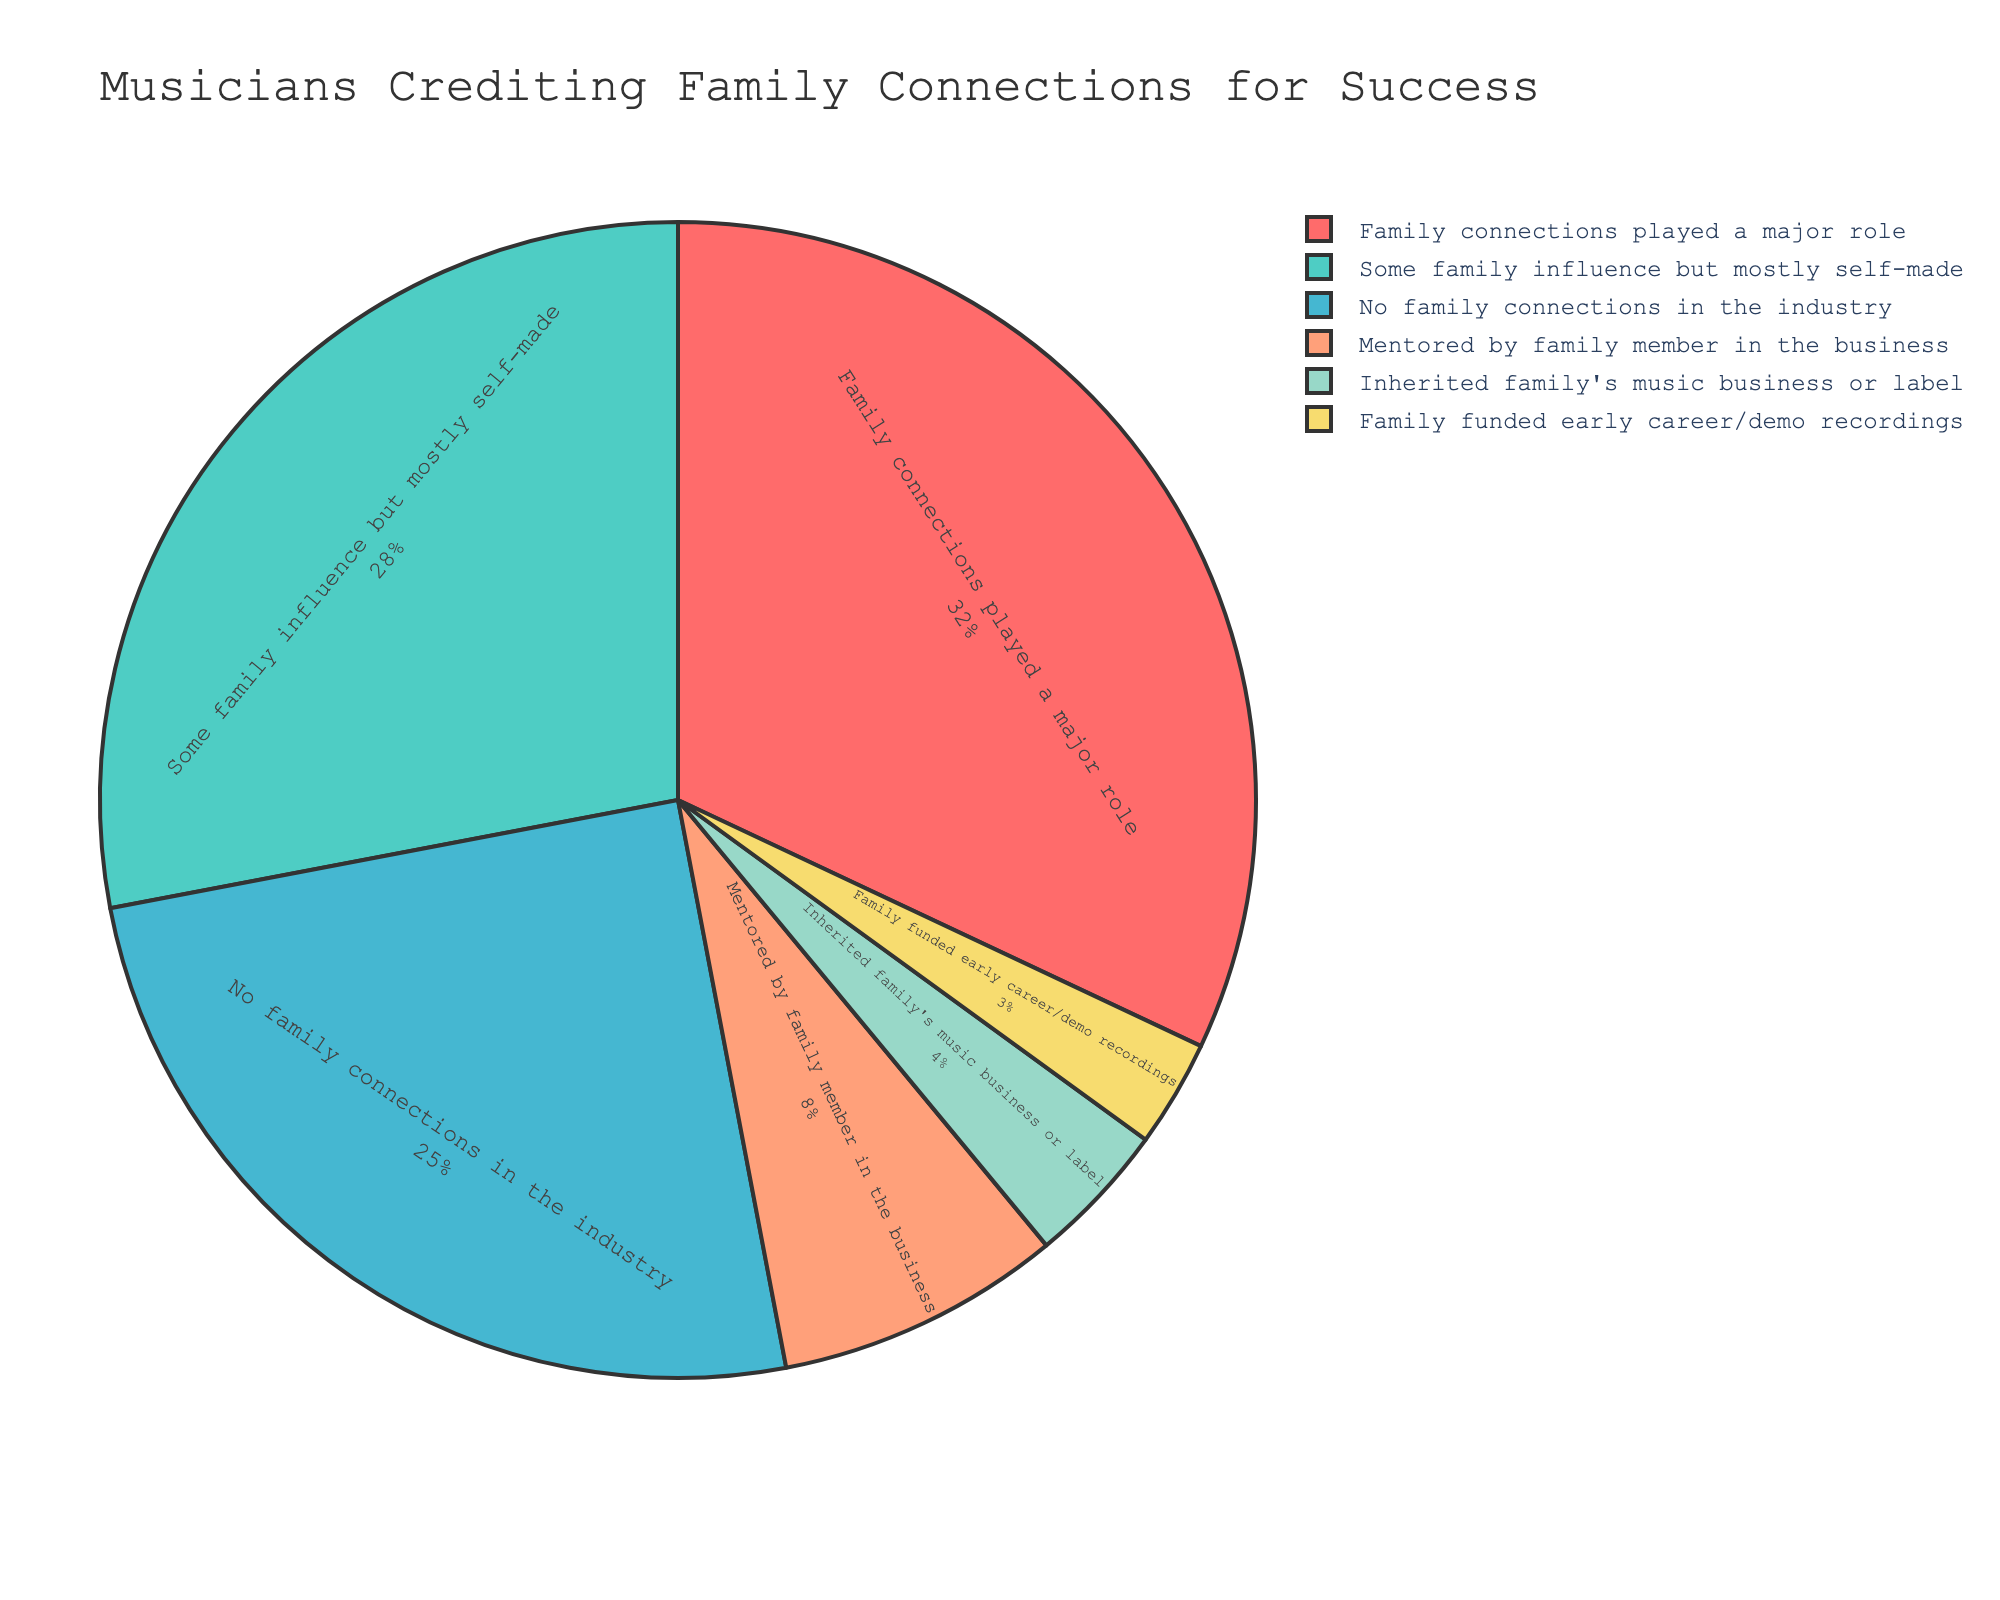Which category has the highest percentage? From the pie chart, "Family connections played a major role" has the largest slice, indicating it has the highest percentage.
Answer: Family connections played a major role What is the combined percentage of musicians who had some family influence but are mostly self-made and those mentored by a family member in the business? To determine the combined percentage, add the percentages of "Some family influence but mostly self-made" (28%) and "Mentored by family member in the business" (8%): 28 + 8 = 36%
Answer: 36% Which category has a lower percentage than those who had no family connections in the industry? "Inherited family's music business or label" (4%) and "Family funded early career/demo recordings" (3%) have lower percentages compared to "No family connections in the industry" (25%).
Answer: Inherited family's music business or label and Family funded early career/demo recordings How does the percentage of musicians who credit family connections as having played a major role compare to those who had no family connections in the industry? "Family connections played a major role" is 32%, which is higher than "No family connections in the industry" at 25%. The difference is 32 - 25 = 7%.
Answer: 32% vs 25%, with a difference of 7% What is the total percentage of musicians who credited some form of family influence (either major, some, mentoring, inheritance, or funding)? Add the percentages of all categories except "No family connections in the industry" which is 32 + 28 + 8 + 4 + 3 = 75%.
Answer: 75% Which categories together account for more than half of the total percentage? Add the percentages sequentially until exceeding half (50%): 32% (Family connections played a major role) + 28% (Some family influence but mostly self-made) = 60%, which is more than 50%.
Answer: Family connections played a major role and Some family influence but mostly self-made How many times greater is the percentage of musicians who had family connections play a major role compared to those who had family-funded early career/demo recordings? To find how many times greater, divide the percentage of "Family connections played a major role" (32%) by "Family funded early career/demo recordings" (3%): 32 / 3 ≈ 10.67 times greater.
Answer: About 10.67 times Which two categories have almost equal percentages contributing to the chart? "Some family influence but mostly self-made" (28%) and "No family connections in the industry" (25%) have almost equal percentages with a difference of only 3%.
Answer: Some family influence but mostly self-made and No family connections in the industry What visual element is used to represent the data distribution in the chart for this dataset? The data distribution is represented using slices of a pie chart, with each slice depicting a category’s percentage.
Answer: Slices of a pie chart What percentage of musicians had either mentored family members or inherited the family’s music business or label? Add the percentages of "Mentored by family member in the business" (8%) and "Inherited family's music business or label" (4%): 8 + 4 = 12%.
Answer: 12% 